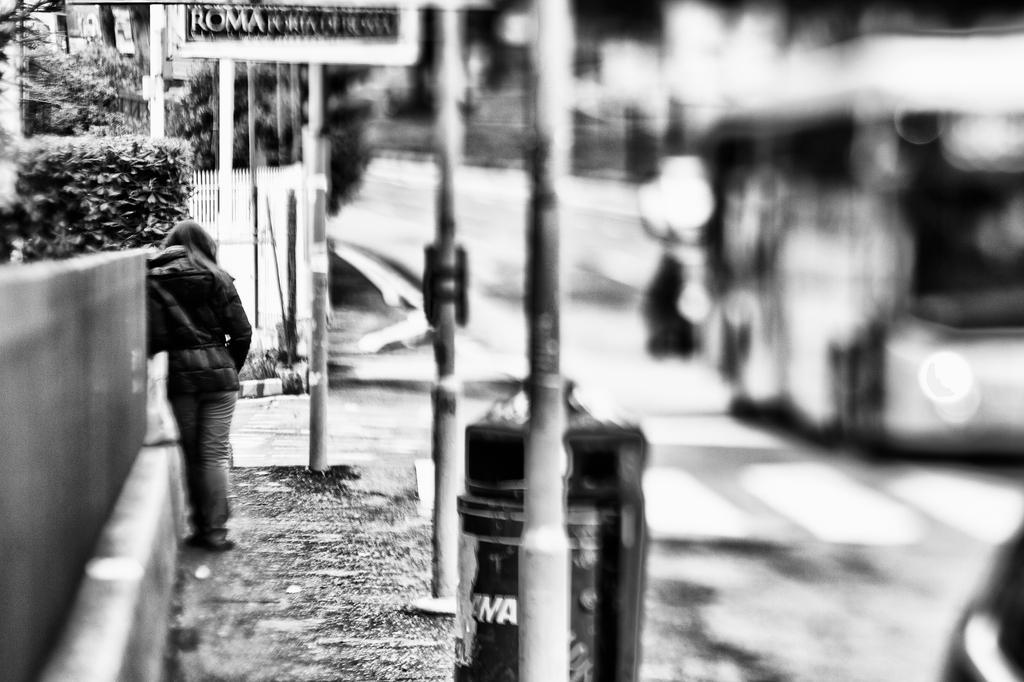How would you summarize this image in a sentence or two? In this image I can see the person with the dress. To the right I can the vehicle on the road, many poles and the dustbin. To the left I can see the wall and the plants. In the background I can see the railing, few more poles and the board. 